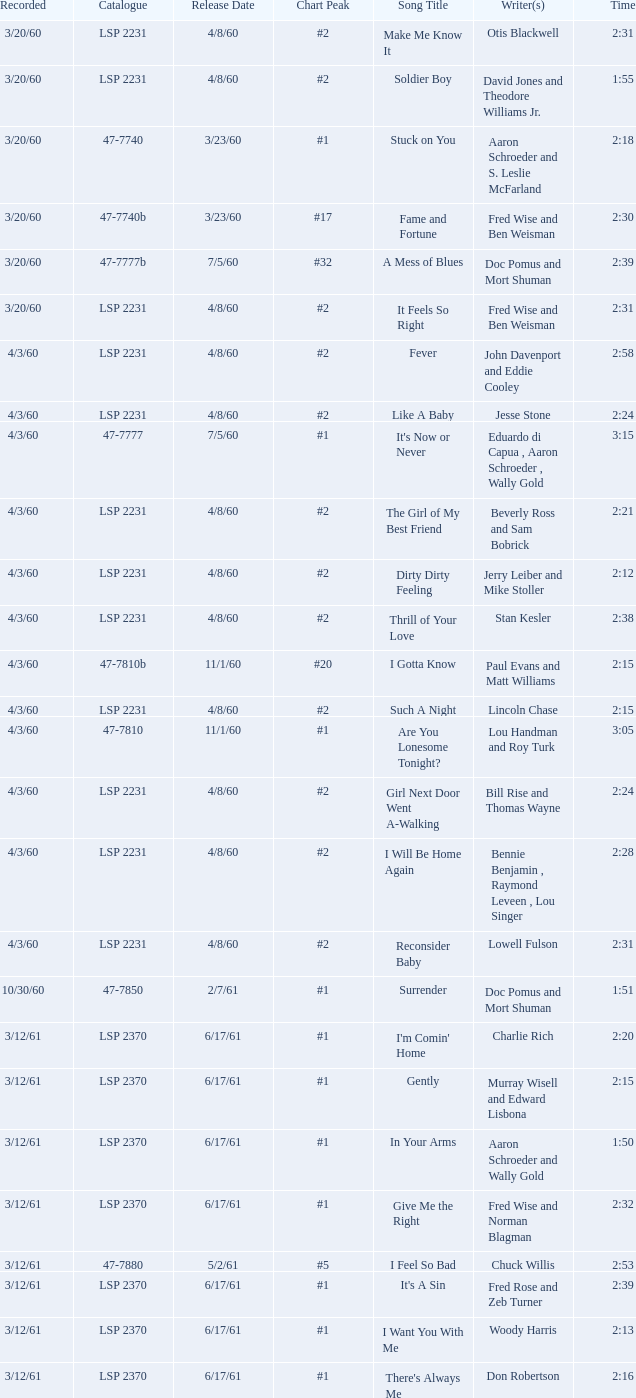On songs that have a release date of 6/17/61, a track larger than 20, and a writer of Woody Harris, what is the chart peak? #1. 